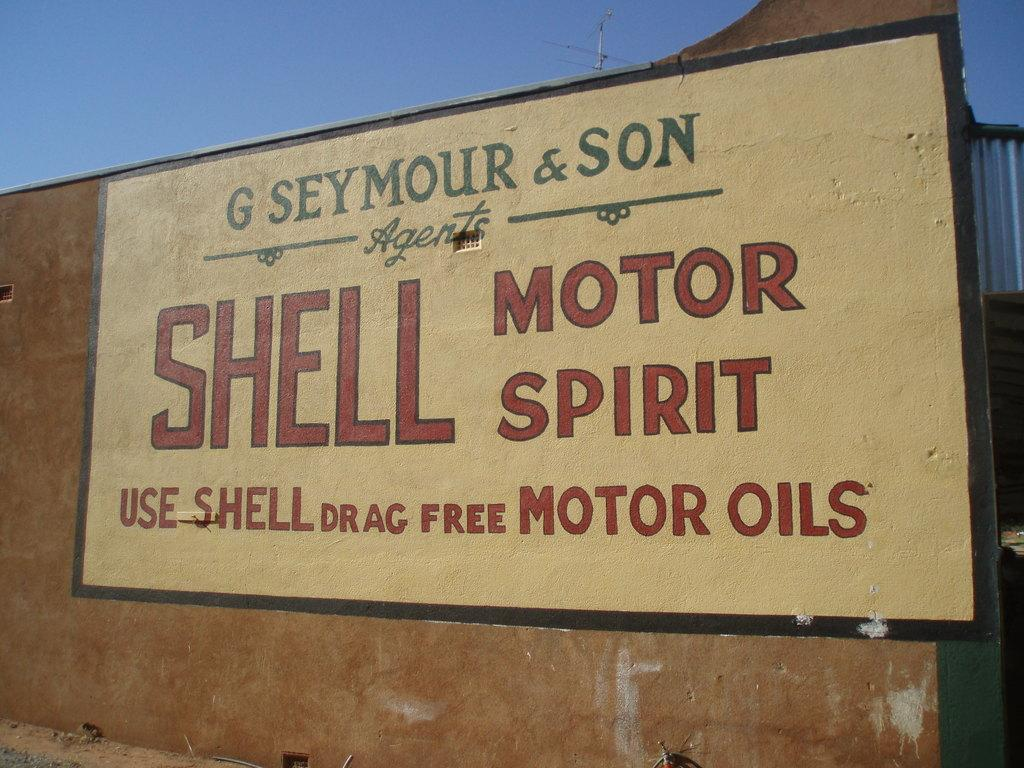<image>
Create a compact narrative representing the image presented. Shell Motor Spirit is a drag free motor oil. 